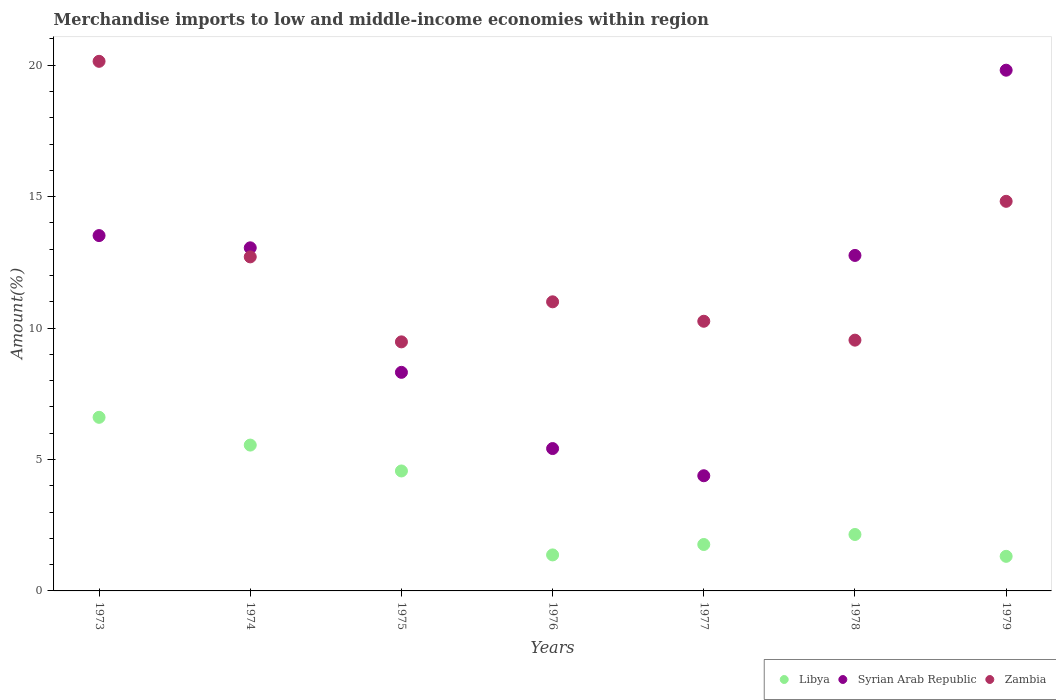Is the number of dotlines equal to the number of legend labels?
Your response must be concise. Yes. What is the percentage of amount earned from merchandise imports in Libya in 1975?
Your answer should be compact. 4.56. Across all years, what is the maximum percentage of amount earned from merchandise imports in Libya?
Provide a short and direct response. 6.61. Across all years, what is the minimum percentage of amount earned from merchandise imports in Zambia?
Your answer should be very brief. 9.48. In which year was the percentage of amount earned from merchandise imports in Zambia maximum?
Offer a terse response. 1973. What is the total percentage of amount earned from merchandise imports in Libya in the graph?
Give a very brief answer. 23.32. What is the difference between the percentage of amount earned from merchandise imports in Libya in 1973 and that in 1974?
Give a very brief answer. 1.06. What is the difference between the percentage of amount earned from merchandise imports in Syrian Arab Republic in 1978 and the percentage of amount earned from merchandise imports in Zambia in 1976?
Your response must be concise. 1.77. What is the average percentage of amount earned from merchandise imports in Zambia per year?
Your answer should be very brief. 12.57. In the year 1973, what is the difference between the percentage of amount earned from merchandise imports in Zambia and percentage of amount earned from merchandise imports in Libya?
Give a very brief answer. 13.54. What is the ratio of the percentage of amount earned from merchandise imports in Zambia in 1974 to that in 1976?
Give a very brief answer. 1.16. What is the difference between the highest and the second highest percentage of amount earned from merchandise imports in Syrian Arab Republic?
Keep it short and to the point. 6.29. What is the difference between the highest and the lowest percentage of amount earned from merchandise imports in Syrian Arab Republic?
Ensure brevity in your answer.  15.43. In how many years, is the percentage of amount earned from merchandise imports in Libya greater than the average percentage of amount earned from merchandise imports in Libya taken over all years?
Offer a very short reply. 3. Is the percentage of amount earned from merchandise imports in Syrian Arab Republic strictly greater than the percentage of amount earned from merchandise imports in Zambia over the years?
Provide a succinct answer. No. Is the percentage of amount earned from merchandise imports in Zambia strictly less than the percentage of amount earned from merchandise imports in Libya over the years?
Offer a terse response. No. How many years are there in the graph?
Make the answer very short. 7. Does the graph contain any zero values?
Keep it short and to the point. No. Does the graph contain grids?
Ensure brevity in your answer.  No. Where does the legend appear in the graph?
Your answer should be compact. Bottom right. What is the title of the graph?
Your response must be concise. Merchandise imports to low and middle-income economies within region. Does "Belize" appear as one of the legend labels in the graph?
Your answer should be compact. No. What is the label or title of the Y-axis?
Make the answer very short. Amount(%). What is the Amount(%) in Libya in 1973?
Your response must be concise. 6.61. What is the Amount(%) in Syrian Arab Republic in 1973?
Provide a succinct answer. 13.52. What is the Amount(%) of Zambia in 1973?
Make the answer very short. 20.15. What is the Amount(%) of Libya in 1974?
Your answer should be compact. 5.55. What is the Amount(%) in Syrian Arab Republic in 1974?
Provide a short and direct response. 13.05. What is the Amount(%) in Zambia in 1974?
Make the answer very short. 12.71. What is the Amount(%) in Libya in 1975?
Provide a succinct answer. 4.56. What is the Amount(%) of Syrian Arab Republic in 1975?
Provide a succinct answer. 8.32. What is the Amount(%) of Zambia in 1975?
Provide a short and direct response. 9.48. What is the Amount(%) in Libya in 1976?
Provide a short and direct response. 1.37. What is the Amount(%) of Syrian Arab Republic in 1976?
Ensure brevity in your answer.  5.42. What is the Amount(%) of Zambia in 1976?
Provide a short and direct response. 11. What is the Amount(%) in Libya in 1977?
Your answer should be compact. 1.77. What is the Amount(%) of Syrian Arab Republic in 1977?
Your answer should be very brief. 4.38. What is the Amount(%) of Zambia in 1977?
Provide a succinct answer. 10.26. What is the Amount(%) of Libya in 1978?
Offer a terse response. 2.15. What is the Amount(%) in Syrian Arab Republic in 1978?
Your answer should be compact. 12.76. What is the Amount(%) of Zambia in 1978?
Your answer should be compact. 9.54. What is the Amount(%) in Libya in 1979?
Provide a short and direct response. 1.32. What is the Amount(%) of Syrian Arab Republic in 1979?
Your answer should be compact. 19.81. What is the Amount(%) in Zambia in 1979?
Ensure brevity in your answer.  14.82. Across all years, what is the maximum Amount(%) of Libya?
Provide a short and direct response. 6.61. Across all years, what is the maximum Amount(%) of Syrian Arab Republic?
Your answer should be compact. 19.81. Across all years, what is the maximum Amount(%) in Zambia?
Your answer should be compact. 20.15. Across all years, what is the minimum Amount(%) in Libya?
Provide a succinct answer. 1.32. Across all years, what is the minimum Amount(%) of Syrian Arab Republic?
Offer a terse response. 4.38. Across all years, what is the minimum Amount(%) in Zambia?
Provide a succinct answer. 9.48. What is the total Amount(%) of Libya in the graph?
Offer a terse response. 23.32. What is the total Amount(%) in Syrian Arab Republic in the graph?
Make the answer very short. 77.27. What is the total Amount(%) of Zambia in the graph?
Make the answer very short. 87.96. What is the difference between the Amount(%) of Libya in 1973 and that in 1974?
Give a very brief answer. 1.06. What is the difference between the Amount(%) of Syrian Arab Republic in 1973 and that in 1974?
Your response must be concise. 0.47. What is the difference between the Amount(%) of Zambia in 1973 and that in 1974?
Provide a short and direct response. 7.44. What is the difference between the Amount(%) in Libya in 1973 and that in 1975?
Provide a short and direct response. 2.04. What is the difference between the Amount(%) of Syrian Arab Republic in 1973 and that in 1975?
Your answer should be compact. 5.2. What is the difference between the Amount(%) in Zambia in 1973 and that in 1975?
Offer a very short reply. 10.67. What is the difference between the Amount(%) of Libya in 1973 and that in 1976?
Give a very brief answer. 5.24. What is the difference between the Amount(%) of Syrian Arab Republic in 1973 and that in 1976?
Give a very brief answer. 8.1. What is the difference between the Amount(%) of Zambia in 1973 and that in 1976?
Your response must be concise. 9.15. What is the difference between the Amount(%) of Libya in 1973 and that in 1977?
Give a very brief answer. 4.84. What is the difference between the Amount(%) in Syrian Arab Republic in 1973 and that in 1977?
Offer a very short reply. 9.14. What is the difference between the Amount(%) in Zambia in 1973 and that in 1977?
Your response must be concise. 9.89. What is the difference between the Amount(%) in Libya in 1973 and that in 1978?
Ensure brevity in your answer.  4.46. What is the difference between the Amount(%) of Syrian Arab Republic in 1973 and that in 1978?
Your answer should be compact. 0.76. What is the difference between the Amount(%) of Zambia in 1973 and that in 1978?
Give a very brief answer. 10.61. What is the difference between the Amount(%) of Libya in 1973 and that in 1979?
Make the answer very short. 5.29. What is the difference between the Amount(%) of Syrian Arab Republic in 1973 and that in 1979?
Provide a succinct answer. -6.29. What is the difference between the Amount(%) of Zambia in 1973 and that in 1979?
Keep it short and to the point. 5.33. What is the difference between the Amount(%) of Libya in 1974 and that in 1975?
Provide a short and direct response. 0.98. What is the difference between the Amount(%) in Syrian Arab Republic in 1974 and that in 1975?
Provide a short and direct response. 4.74. What is the difference between the Amount(%) of Zambia in 1974 and that in 1975?
Provide a short and direct response. 3.23. What is the difference between the Amount(%) in Libya in 1974 and that in 1976?
Offer a terse response. 4.18. What is the difference between the Amount(%) of Syrian Arab Republic in 1974 and that in 1976?
Offer a very short reply. 7.64. What is the difference between the Amount(%) in Zambia in 1974 and that in 1976?
Your answer should be compact. 1.71. What is the difference between the Amount(%) of Libya in 1974 and that in 1977?
Keep it short and to the point. 3.78. What is the difference between the Amount(%) of Syrian Arab Republic in 1974 and that in 1977?
Your response must be concise. 8.67. What is the difference between the Amount(%) of Zambia in 1974 and that in 1977?
Give a very brief answer. 2.45. What is the difference between the Amount(%) in Libya in 1974 and that in 1978?
Keep it short and to the point. 3.4. What is the difference between the Amount(%) in Syrian Arab Republic in 1974 and that in 1978?
Offer a very short reply. 0.29. What is the difference between the Amount(%) of Zambia in 1974 and that in 1978?
Your answer should be compact. 3.17. What is the difference between the Amount(%) of Libya in 1974 and that in 1979?
Your response must be concise. 4.23. What is the difference between the Amount(%) of Syrian Arab Republic in 1974 and that in 1979?
Offer a very short reply. -6.76. What is the difference between the Amount(%) in Zambia in 1974 and that in 1979?
Give a very brief answer. -2.11. What is the difference between the Amount(%) of Libya in 1975 and that in 1976?
Provide a short and direct response. 3.19. What is the difference between the Amount(%) in Syrian Arab Republic in 1975 and that in 1976?
Your response must be concise. 2.9. What is the difference between the Amount(%) of Zambia in 1975 and that in 1976?
Make the answer very short. -1.52. What is the difference between the Amount(%) of Libya in 1975 and that in 1977?
Offer a terse response. 2.8. What is the difference between the Amount(%) of Syrian Arab Republic in 1975 and that in 1977?
Your answer should be compact. 3.93. What is the difference between the Amount(%) in Zambia in 1975 and that in 1977?
Your answer should be very brief. -0.78. What is the difference between the Amount(%) in Libya in 1975 and that in 1978?
Offer a terse response. 2.42. What is the difference between the Amount(%) of Syrian Arab Republic in 1975 and that in 1978?
Provide a succinct answer. -4.45. What is the difference between the Amount(%) in Zambia in 1975 and that in 1978?
Provide a succinct answer. -0.07. What is the difference between the Amount(%) in Libya in 1975 and that in 1979?
Make the answer very short. 3.25. What is the difference between the Amount(%) of Syrian Arab Republic in 1975 and that in 1979?
Provide a succinct answer. -11.5. What is the difference between the Amount(%) in Zambia in 1975 and that in 1979?
Your answer should be very brief. -5.35. What is the difference between the Amount(%) of Libya in 1976 and that in 1977?
Offer a terse response. -0.4. What is the difference between the Amount(%) in Syrian Arab Republic in 1976 and that in 1977?
Provide a short and direct response. 1.03. What is the difference between the Amount(%) of Zambia in 1976 and that in 1977?
Your response must be concise. 0.74. What is the difference between the Amount(%) in Libya in 1976 and that in 1978?
Your answer should be very brief. -0.78. What is the difference between the Amount(%) in Syrian Arab Republic in 1976 and that in 1978?
Your response must be concise. -7.35. What is the difference between the Amount(%) of Zambia in 1976 and that in 1978?
Provide a short and direct response. 1.46. What is the difference between the Amount(%) in Libya in 1976 and that in 1979?
Offer a terse response. 0.05. What is the difference between the Amount(%) in Syrian Arab Republic in 1976 and that in 1979?
Your answer should be compact. -14.4. What is the difference between the Amount(%) in Zambia in 1976 and that in 1979?
Your answer should be very brief. -3.82. What is the difference between the Amount(%) of Libya in 1977 and that in 1978?
Give a very brief answer. -0.38. What is the difference between the Amount(%) in Syrian Arab Republic in 1977 and that in 1978?
Offer a very short reply. -8.38. What is the difference between the Amount(%) in Zambia in 1977 and that in 1978?
Keep it short and to the point. 0.72. What is the difference between the Amount(%) of Libya in 1977 and that in 1979?
Provide a succinct answer. 0.45. What is the difference between the Amount(%) in Syrian Arab Republic in 1977 and that in 1979?
Provide a short and direct response. -15.43. What is the difference between the Amount(%) of Zambia in 1977 and that in 1979?
Your response must be concise. -4.56. What is the difference between the Amount(%) in Libya in 1978 and that in 1979?
Your response must be concise. 0.83. What is the difference between the Amount(%) in Syrian Arab Republic in 1978 and that in 1979?
Offer a very short reply. -7.05. What is the difference between the Amount(%) in Zambia in 1978 and that in 1979?
Your answer should be compact. -5.28. What is the difference between the Amount(%) of Libya in 1973 and the Amount(%) of Syrian Arab Republic in 1974?
Your answer should be very brief. -6.45. What is the difference between the Amount(%) in Libya in 1973 and the Amount(%) in Zambia in 1974?
Your response must be concise. -6.1. What is the difference between the Amount(%) of Syrian Arab Republic in 1973 and the Amount(%) of Zambia in 1974?
Offer a terse response. 0.81. What is the difference between the Amount(%) of Libya in 1973 and the Amount(%) of Syrian Arab Republic in 1975?
Offer a terse response. -1.71. What is the difference between the Amount(%) of Libya in 1973 and the Amount(%) of Zambia in 1975?
Provide a succinct answer. -2.87. What is the difference between the Amount(%) of Syrian Arab Republic in 1973 and the Amount(%) of Zambia in 1975?
Give a very brief answer. 4.04. What is the difference between the Amount(%) of Libya in 1973 and the Amount(%) of Syrian Arab Republic in 1976?
Keep it short and to the point. 1.19. What is the difference between the Amount(%) of Libya in 1973 and the Amount(%) of Zambia in 1976?
Provide a short and direct response. -4.39. What is the difference between the Amount(%) of Syrian Arab Republic in 1973 and the Amount(%) of Zambia in 1976?
Provide a short and direct response. 2.52. What is the difference between the Amount(%) of Libya in 1973 and the Amount(%) of Syrian Arab Republic in 1977?
Your answer should be compact. 2.22. What is the difference between the Amount(%) in Libya in 1973 and the Amount(%) in Zambia in 1977?
Give a very brief answer. -3.65. What is the difference between the Amount(%) of Syrian Arab Republic in 1973 and the Amount(%) of Zambia in 1977?
Provide a short and direct response. 3.26. What is the difference between the Amount(%) in Libya in 1973 and the Amount(%) in Syrian Arab Republic in 1978?
Give a very brief answer. -6.16. What is the difference between the Amount(%) of Libya in 1973 and the Amount(%) of Zambia in 1978?
Ensure brevity in your answer.  -2.94. What is the difference between the Amount(%) in Syrian Arab Republic in 1973 and the Amount(%) in Zambia in 1978?
Ensure brevity in your answer.  3.98. What is the difference between the Amount(%) in Libya in 1973 and the Amount(%) in Syrian Arab Republic in 1979?
Make the answer very short. -13.21. What is the difference between the Amount(%) of Libya in 1973 and the Amount(%) of Zambia in 1979?
Make the answer very short. -8.22. What is the difference between the Amount(%) of Syrian Arab Republic in 1973 and the Amount(%) of Zambia in 1979?
Your response must be concise. -1.3. What is the difference between the Amount(%) of Libya in 1974 and the Amount(%) of Syrian Arab Republic in 1975?
Provide a short and direct response. -2.77. What is the difference between the Amount(%) in Libya in 1974 and the Amount(%) in Zambia in 1975?
Make the answer very short. -3.93. What is the difference between the Amount(%) of Syrian Arab Republic in 1974 and the Amount(%) of Zambia in 1975?
Keep it short and to the point. 3.58. What is the difference between the Amount(%) in Libya in 1974 and the Amount(%) in Syrian Arab Republic in 1976?
Your answer should be compact. 0.13. What is the difference between the Amount(%) of Libya in 1974 and the Amount(%) of Zambia in 1976?
Provide a succinct answer. -5.45. What is the difference between the Amount(%) of Syrian Arab Republic in 1974 and the Amount(%) of Zambia in 1976?
Keep it short and to the point. 2.05. What is the difference between the Amount(%) of Libya in 1974 and the Amount(%) of Syrian Arab Republic in 1977?
Offer a terse response. 1.17. What is the difference between the Amount(%) in Libya in 1974 and the Amount(%) in Zambia in 1977?
Give a very brief answer. -4.71. What is the difference between the Amount(%) in Syrian Arab Republic in 1974 and the Amount(%) in Zambia in 1977?
Provide a short and direct response. 2.79. What is the difference between the Amount(%) of Libya in 1974 and the Amount(%) of Syrian Arab Republic in 1978?
Offer a very short reply. -7.22. What is the difference between the Amount(%) in Libya in 1974 and the Amount(%) in Zambia in 1978?
Make the answer very short. -3.99. What is the difference between the Amount(%) of Syrian Arab Republic in 1974 and the Amount(%) of Zambia in 1978?
Make the answer very short. 3.51. What is the difference between the Amount(%) of Libya in 1974 and the Amount(%) of Syrian Arab Republic in 1979?
Offer a very short reply. -14.26. What is the difference between the Amount(%) of Libya in 1974 and the Amount(%) of Zambia in 1979?
Your answer should be compact. -9.27. What is the difference between the Amount(%) in Syrian Arab Republic in 1974 and the Amount(%) in Zambia in 1979?
Keep it short and to the point. -1.77. What is the difference between the Amount(%) in Libya in 1975 and the Amount(%) in Syrian Arab Republic in 1976?
Make the answer very short. -0.85. What is the difference between the Amount(%) of Libya in 1975 and the Amount(%) of Zambia in 1976?
Offer a terse response. -6.44. What is the difference between the Amount(%) of Syrian Arab Republic in 1975 and the Amount(%) of Zambia in 1976?
Offer a terse response. -2.68. What is the difference between the Amount(%) in Libya in 1975 and the Amount(%) in Syrian Arab Republic in 1977?
Make the answer very short. 0.18. What is the difference between the Amount(%) of Libya in 1975 and the Amount(%) of Zambia in 1977?
Your response must be concise. -5.7. What is the difference between the Amount(%) of Syrian Arab Republic in 1975 and the Amount(%) of Zambia in 1977?
Ensure brevity in your answer.  -1.94. What is the difference between the Amount(%) in Libya in 1975 and the Amount(%) in Syrian Arab Republic in 1978?
Offer a very short reply. -8.2. What is the difference between the Amount(%) in Libya in 1975 and the Amount(%) in Zambia in 1978?
Keep it short and to the point. -4.98. What is the difference between the Amount(%) of Syrian Arab Republic in 1975 and the Amount(%) of Zambia in 1978?
Offer a very short reply. -1.22. What is the difference between the Amount(%) of Libya in 1975 and the Amount(%) of Syrian Arab Republic in 1979?
Provide a succinct answer. -15.25. What is the difference between the Amount(%) in Libya in 1975 and the Amount(%) in Zambia in 1979?
Ensure brevity in your answer.  -10.26. What is the difference between the Amount(%) of Syrian Arab Republic in 1975 and the Amount(%) of Zambia in 1979?
Offer a terse response. -6.51. What is the difference between the Amount(%) of Libya in 1976 and the Amount(%) of Syrian Arab Republic in 1977?
Offer a very short reply. -3.01. What is the difference between the Amount(%) of Libya in 1976 and the Amount(%) of Zambia in 1977?
Offer a terse response. -8.89. What is the difference between the Amount(%) of Syrian Arab Republic in 1976 and the Amount(%) of Zambia in 1977?
Give a very brief answer. -4.84. What is the difference between the Amount(%) in Libya in 1976 and the Amount(%) in Syrian Arab Republic in 1978?
Make the answer very short. -11.39. What is the difference between the Amount(%) in Libya in 1976 and the Amount(%) in Zambia in 1978?
Offer a very short reply. -8.17. What is the difference between the Amount(%) in Syrian Arab Republic in 1976 and the Amount(%) in Zambia in 1978?
Make the answer very short. -4.12. What is the difference between the Amount(%) of Libya in 1976 and the Amount(%) of Syrian Arab Republic in 1979?
Provide a succinct answer. -18.44. What is the difference between the Amount(%) of Libya in 1976 and the Amount(%) of Zambia in 1979?
Give a very brief answer. -13.45. What is the difference between the Amount(%) in Syrian Arab Republic in 1976 and the Amount(%) in Zambia in 1979?
Provide a succinct answer. -9.41. What is the difference between the Amount(%) in Libya in 1977 and the Amount(%) in Syrian Arab Republic in 1978?
Keep it short and to the point. -11. What is the difference between the Amount(%) in Libya in 1977 and the Amount(%) in Zambia in 1978?
Make the answer very short. -7.78. What is the difference between the Amount(%) of Syrian Arab Republic in 1977 and the Amount(%) of Zambia in 1978?
Make the answer very short. -5.16. What is the difference between the Amount(%) of Libya in 1977 and the Amount(%) of Syrian Arab Republic in 1979?
Provide a succinct answer. -18.05. What is the difference between the Amount(%) in Libya in 1977 and the Amount(%) in Zambia in 1979?
Give a very brief answer. -13.06. What is the difference between the Amount(%) in Syrian Arab Republic in 1977 and the Amount(%) in Zambia in 1979?
Your answer should be very brief. -10.44. What is the difference between the Amount(%) of Libya in 1978 and the Amount(%) of Syrian Arab Republic in 1979?
Ensure brevity in your answer.  -17.66. What is the difference between the Amount(%) in Libya in 1978 and the Amount(%) in Zambia in 1979?
Your answer should be very brief. -12.68. What is the difference between the Amount(%) of Syrian Arab Republic in 1978 and the Amount(%) of Zambia in 1979?
Provide a succinct answer. -2.06. What is the average Amount(%) of Libya per year?
Your answer should be very brief. 3.33. What is the average Amount(%) of Syrian Arab Republic per year?
Provide a short and direct response. 11.04. What is the average Amount(%) of Zambia per year?
Provide a short and direct response. 12.57. In the year 1973, what is the difference between the Amount(%) in Libya and Amount(%) in Syrian Arab Republic?
Give a very brief answer. -6.91. In the year 1973, what is the difference between the Amount(%) in Libya and Amount(%) in Zambia?
Make the answer very short. -13.54. In the year 1973, what is the difference between the Amount(%) of Syrian Arab Republic and Amount(%) of Zambia?
Offer a terse response. -6.63. In the year 1974, what is the difference between the Amount(%) in Libya and Amount(%) in Syrian Arab Republic?
Your answer should be compact. -7.51. In the year 1974, what is the difference between the Amount(%) in Libya and Amount(%) in Zambia?
Ensure brevity in your answer.  -7.16. In the year 1974, what is the difference between the Amount(%) in Syrian Arab Republic and Amount(%) in Zambia?
Keep it short and to the point. 0.34. In the year 1975, what is the difference between the Amount(%) in Libya and Amount(%) in Syrian Arab Republic?
Offer a terse response. -3.75. In the year 1975, what is the difference between the Amount(%) in Libya and Amount(%) in Zambia?
Offer a very short reply. -4.91. In the year 1975, what is the difference between the Amount(%) in Syrian Arab Republic and Amount(%) in Zambia?
Keep it short and to the point. -1.16. In the year 1976, what is the difference between the Amount(%) of Libya and Amount(%) of Syrian Arab Republic?
Provide a succinct answer. -4.05. In the year 1976, what is the difference between the Amount(%) of Libya and Amount(%) of Zambia?
Your response must be concise. -9.63. In the year 1976, what is the difference between the Amount(%) in Syrian Arab Republic and Amount(%) in Zambia?
Offer a very short reply. -5.58. In the year 1977, what is the difference between the Amount(%) in Libya and Amount(%) in Syrian Arab Republic?
Make the answer very short. -2.62. In the year 1977, what is the difference between the Amount(%) of Libya and Amount(%) of Zambia?
Provide a short and direct response. -8.49. In the year 1977, what is the difference between the Amount(%) of Syrian Arab Republic and Amount(%) of Zambia?
Provide a short and direct response. -5.88. In the year 1978, what is the difference between the Amount(%) in Libya and Amount(%) in Syrian Arab Republic?
Offer a very short reply. -10.62. In the year 1978, what is the difference between the Amount(%) of Libya and Amount(%) of Zambia?
Make the answer very short. -7.39. In the year 1978, what is the difference between the Amount(%) of Syrian Arab Republic and Amount(%) of Zambia?
Provide a short and direct response. 3.22. In the year 1979, what is the difference between the Amount(%) in Libya and Amount(%) in Syrian Arab Republic?
Your response must be concise. -18.5. In the year 1979, what is the difference between the Amount(%) in Libya and Amount(%) in Zambia?
Offer a terse response. -13.51. In the year 1979, what is the difference between the Amount(%) of Syrian Arab Republic and Amount(%) of Zambia?
Offer a terse response. 4.99. What is the ratio of the Amount(%) in Libya in 1973 to that in 1974?
Give a very brief answer. 1.19. What is the ratio of the Amount(%) of Syrian Arab Republic in 1973 to that in 1974?
Keep it short and to the point. 1.04. What is the ratio of the Amount(%) in Zambia in 1973 to that in 1974?
Your response must be concise. 1.59. What is the ratio of the Amount(%) of Libya in 1973 to that in 1975?
Your response must be concise. 1.45. What is the ratio of the Amount(%) of Syrian Arab Republic in 1973 to that in 1975?
Offer a terse response. 1.63. What is the ratio of the Amount(%) of Zambia in 1973 to that in 1975?
Your answer should be compact. 2.13. What is the ratio of the Amount(%) of Libya in 1973 to that in 1976?
Give a very brief answer. 4.82. What is the ratio of the Amount(%) of Syrian Arab Republic in 1973 to that in 1976?
Provide a succinct answer. 2.5. What is the ratio of the Amount(%) in Zambia in 1973 to that in 1976?
Provide a succinct answer. 1.83. What is the ratio of the Amount(%) in Libya in 1973 to that in 1977?
Your response must be concise. 3.74. What is the ratio of the Amount(%) of Syrian Arab Republic in 1973 to that in 1977?
Provide a succinct answer. 3.09. What is the ratio of the Amount(%) in Zambia in 1973 to that in 1977?
Ensure brevity in your answer.  1.96. What is the ratio of the Amount(%) in Libya in 1973 to that in 1978?
Make the answer very short. 3.08. What is the ratio of the Amount(%) in Syrian Arab Republic in 1973 to that in 1978?
Provide a succinct answer. 1.06. What is the ratio of the Amount(%) in Zambia in 1973 to that in 1978?
Your answer should be compact. 2.11. What is the ratio of the Amount(%) of Libya in 1973 to that in 1979?
Give a very brief answer. 5.02. What is the ratio of the Amount(%) of Syrian Arab Republic in 1973 to that in 1979?
Offer a terse response. 0.68. What is the ratio of the Amount(%) in Zambia in 1973 to that in 1979?
Your answer should be very brief. 1.36. What is the ratio of the Amount(%) of Libya in 1974 to that in 1975?
Provide a short and direct response. 1.22. What is the ratio of the Amount(%) of Syrian Arab Republic in 1974 to that in 1975?
Ensure brevity in your answer.  1.57. What is the ratio of the Amount(%) of Zambia in 1974 to that in 1975?
Keep it short and to the point. 1.34. What is the ratio of the Amount(%) in Libya in 1974 to that in 1976?
Keep it short and to the point. 4.05. What is the ratio of the Amount(%) in Syrian Arab Republic in 1974 to that in 1976?
Provide a short and direct response. 2.41. What is the ratio of the Amount(%) of Zambia in 1974 to that in 1976?
Provide a succinct answer. 1.16. What is the ratio of the Amount(%) in Libya in 1974 to that in 1977?
Offer a very short reply. 3.14. What is the ratio of the Amount(%) of Syrian Arab Republic in 1974 to that in 1977?
Provide a short and direct response. 2.98. What is the ratio of the Amount(%) of Zambia in 1974 to that in 1977?
Your answer should be very brief. 1.24. What is the ratio of the Amount(%) in Libya in 1974 to that in 1978?
Keep it short and to the point. 2.58. What is the ratio of the Amount(%) of Syrian Arab Republic in 1974 to that in 1978?
Provide a short and direct response. 1.02. What is the ratio of the Amount(%) in Zambia in 1974 to that in 1978?
Your answer should be compact. 1.33. What is the ratio of the Amount(%) of Libya in 1974 to that in 1979?
Keep it short and to the point. 4.22. What is the ratio of the Amount(%) in Syrian Arab Republic in 1974 to that in 1979?
Provide a succinct answer. 0.66. What is the ratio of the Amount(%) in Zambia in 1974 to that in 1979?
Ensure brevity in your answer.  0.86. What is the ratio of the Amount(%) of Libya in 1975 to that in 1976?
Ensure brevity in your answer.  3.33. What is the ratio of the Amount(%) of Syrian Arab Republic in 1975 to that in 1976?
Your answer should be compact. 1.54. What is the ratio of the Amount(%) in Zambia in 1975 to that in 1976?
Offer a terse response. 0.86. What is the ratio of the Amount(%) of Libya in 1975 to that in 1977?
Your response must be concise. 2.58. What is the ratio of the Amount(%) in Syrian Arab Republic in 1975 to that in 1977?
Keep it short and to the point. 1.9. What is the ratio of the Amount(%) of Zambia in 1975 to that in 1977?
Your response must be concise. 0.92. What is the ratio of the Amount(%) of Libya in 1975 to that in 1978?
Your answer should be very brief. 2.13. What is the ratio of the Amount(%) in Syrian Arab Republic in 1975 to that in 1978?
Offer a very short reply. 0.65. What is the ratio of the Amount(%) of Libya in 1975 to that in 1979?
Your answer should be very brief. 3.47. What is the ratio of the Amount(%) of Syrian Arab Republic in 1975 to that in 1979?
Keep it short and to the point. 0.42. What is the ratio of the Amount(%) of Zambia in 1975 to that in 1979?
Ensure brevity in your answer.  0.64. What is the ratio of the Amount(%) of Libya in 1976 to that in 1977?
Your answer should be very brief. 0.78. What is the ratio of the Amount(%) of Syrian Arab Republic in 1976 to that in 1977?
Make the answer very short. 1.24. What is the ratio of the Amount(%) of Zambia in 1976 to that in 1977?
Your response must be concise. 1.07. What is the ratio of the Amount(%) of Libya in 1976 to that in 1978?
Provide a succinct answer. 0.64. What is the ratio of the Amount(%) in Syrian Arab Republic in 1976 to that in 1978?
Keep it short and to the point. 0.42. What is the ratio of the Amount(%) of Zambia in 1976 to that in 1978?
Give a very brief answer. 1.15. What is the ratio of the Amount(%) of Libya in 1976 to that in 1979?
Your answer should be compact. 1.04. What is the ratio of the Amount(%) of Syrian Arab Republic in 1976 to that in 1979?
Keep it short and to the point. 0.27. What is the ratio of the Amount(%) in Zambia in 1976 to that in 1979?
Offer a terse response. 0.74. What is the ratio of the Amount(%) in Libya in 1977 to that in 1978?
Your answer should be very brief. 0.82. What is the ratio of the Amount(%) in Syrian Arab Republic in 1977 to that in 1978?
Offer a very short reply. 0.34. What is the ratio of the Amount(%) in Zambia in 1977 to that in 1978?
Provide a short and direct response. 1.08. What is the ratio of the Amount(%) in Libya in 1977 to that in 1979?
Ensure brevity in your answer.  1.34. What is the ratio of the Amount(%) of Syrian Arab Republic in 1977 to that in 1979?
Your response must be concise. 0.22. What is the ratio of the Amount(%) of Zambia in 1977 to that in 1979?
Your response must be concise. 0.69. What is the ratio of the Amount(%) in Libya in 1978 to that in 1979?
Your answer should be compact. 1.63. What is the ratio of the Amount(%) in Syrian Arab Republic in 1978 to that in 1979?
Make the answer very short. 0.64. What is the ratio of the Amount(%) of Zambia in 1978 to that in 1979?
Offer a very short reply. 0.64. What is the difference between the highest and the second highest Amount(%) in Libya?
Your response must be concise. 1.06. What is the difference between the highest and the second highest Amount(%) of Syrian Arab Republic?
Ensure brevity in your answer.  6.29. What is the difference between the highest and the second highest Amount(%) in Zambia?
Provide a short and direct response. 5.33. What is the difference between the highest and the lowest Amount(%) in Libya?
Give a very brief answer. 5.29. What is the difference between the highest and the lowest Amount(%) in Syrian Arab Republic?
Make the answer very short. 15.43. What is the difference between the highest and the lowest Amount(%) of Zambia?
Ensure brevity in your answer.  10.67. 